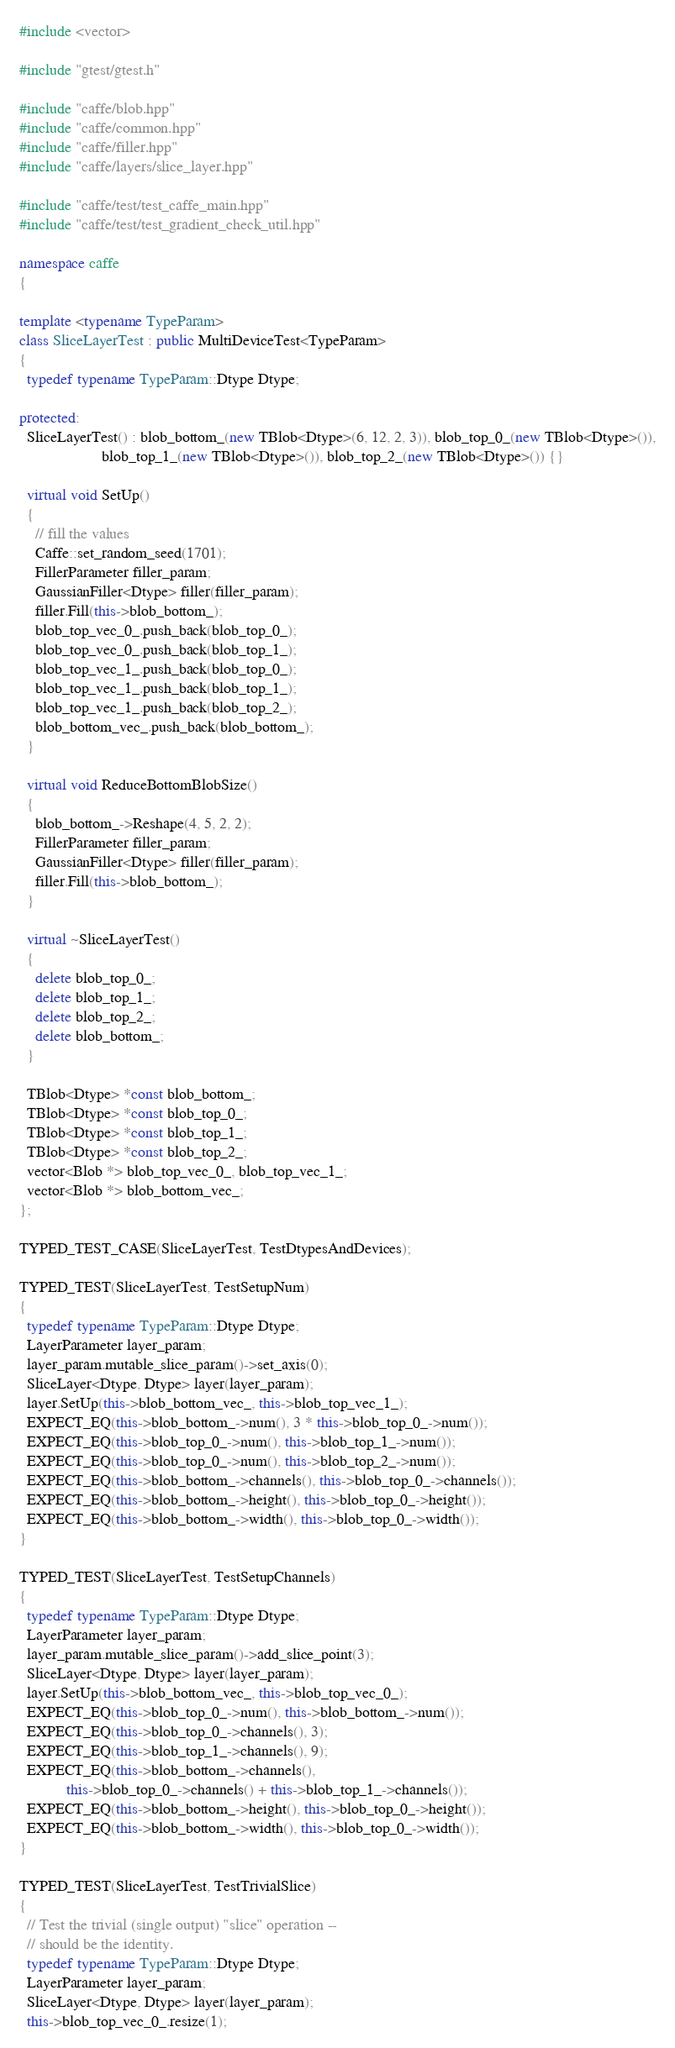Convert code to text. <code><loc_0><loc_0><loc_500><loc_500><_C++_>#include <vector>

#include "gtest/gtest.h"

#include "caffe/blob.hpp"
#include "caffe/common.hpp"
#include "caffe/filler.hpp"
#include "caffe/layers/slice_layer.hpp"

#include "caffe/test/test_caffe_main.hpp"
#include "caffe/test/test_gradient_check_util.hpp"

namespace caffe
{

template <typename TypeParam>
class SliceLayerTest : public MultiDeviceTest<TypeParam>
{
  typedef typename TypeParam::Dtype Dtype;

protected:
  SliceLayerTest() : blob_bottom_(new TBlob<Dtype>(6, 12, 2, 3)), blob_top_0_(new TBlob<Dtype>()),
                     blob_top_1_(new TBlob<Dtype>()), blob_top_2_(new TBlob<Dtype>()) {}

  virtual void SetUp()
  {
    // fill the values
    Caffe::set_random_seed(1701);
    FillerParameter filler_param;
    GaussianFiller<Dtype> filler(filler_param);
    filler.Fill(this->blob_bottom_);
    blob_top_vec_0_.push_back(blob_top_0_);
    blob_top_vec_0_.push_back(blob_top_1_);
    blob_top_vec_1_.push_back(blob_top_0_);
    blob_top_vec_1_.push_back(blob_top_1_);
    blob_top_vec_1_.push_back(blob_top_2_);
    blob_bottom_vec_.push_back(blob_bottom_);
  }

  virtual void ReduceBottomBlobSize()
  {
    blob_bottom_->Reshape(4, 5, 2, 2);
    FillerParameter filler_param;
    GaussianFiller<Dtype> filler(filler_param);
    filler.Fill(this->blob_bottom_);
  }

  virtual ~SliceLayerTest()
  {
    delete blob_top_0_;
    delete blob_top_1_;
    delete blob_top_2_;
    delete blob_bottom_;
  }

  TBlob<Dtype> *const blob_bottom_;
  TBlob<Dtype> *const blob_top_0_;
  TBlob<Dtype> *const blob_top_1_;
  TBlob<Dtype> *const blob_top_2_;
  vector<Blob *> blob_top_vec_0_, blob_top_vec_1_;
  vector<Blob *> blob_bottom_vec_;
};

TYPED_TEST_CASE(SliceLayerTest, TestDtypesAndDevices);

TYPED_TEST(SliceLayerTest, TestSetupNum)
{
  typedef typename TypeParam::Dtype Dtype;
  LayerParameter layer_param;
  layer_param.mutable_slice_param()->set_axis(0);
  SliceLayer<Dtype, Dtype> layer(layer_param);
  layer.SetUp(this->blob_bottom_vec_, this->blob_top_vec_1_);
  EXPECT_EQ(this->blob_bottom_->num(), 3 * this->blob_top_0_->num());
  EXPECT_EQ(this->blob_top_0_->num(), this->blob_top_1_->num());
  EXPECT_EQ(this->blob_top_0_->num(), this->blob_top_2_->num());
  EXPECT_EQ(this->blob_bottom_->channels(), this->blob_top_0_->channels());
  EXPECT_EQ(this->blob_bottom_->height(), this->blob_top_0_->height());
  EXPECT_EQ(this->blob_bottom_->width(), this->blob_top_0_->width());
}

TYPED_TEST(SliceLayerTest, TestSetupChannels)
{
  typedef typename TypeParam::Dtype Dtype;
  LayerParameter layer_param;
  layer_param.mutable_slice_param()->add_slice_point(3);
  SliceLayer<Dtype, Dtype> layer(layer_param);
  layer.SetUp(this->blob_bottom_vec_, this->blob_top_vec_0_);
  EXPECT_EQ(this->blob_top_0_->num(), this->blob_bottom_->num());
  EXPECT_EQ(this->blob_top_0_->channels(), 3);
  EXPECT_EQ(this->blob_top_1_->channels(), 9);
  EXPECT_EQ(this->blob_bottom_->channels(),
            this->blob_top_0_->channels() + this->blob_top_1_->channels());
  EXPECT_EQ(this->blob_bottom_->height(), this->blob_top_0_->height());
  EXPECT_EQ(this->blob_bottom_->width(), this->blob_top_0_->width());
}

TYPED_TEST(SliceLayerTest, TestTrivialSlice)
{
  // Test the trivial (single output) "slice" operation --
  // should be the identity.
  typedef typename TypeParam::Dtype Dtype;
  LayerParameter layer_param;
  SliceLayer<Dtype, Dtype> layer(layer_param);
  this->blob_top_vec_0_.resize(1);</code> 